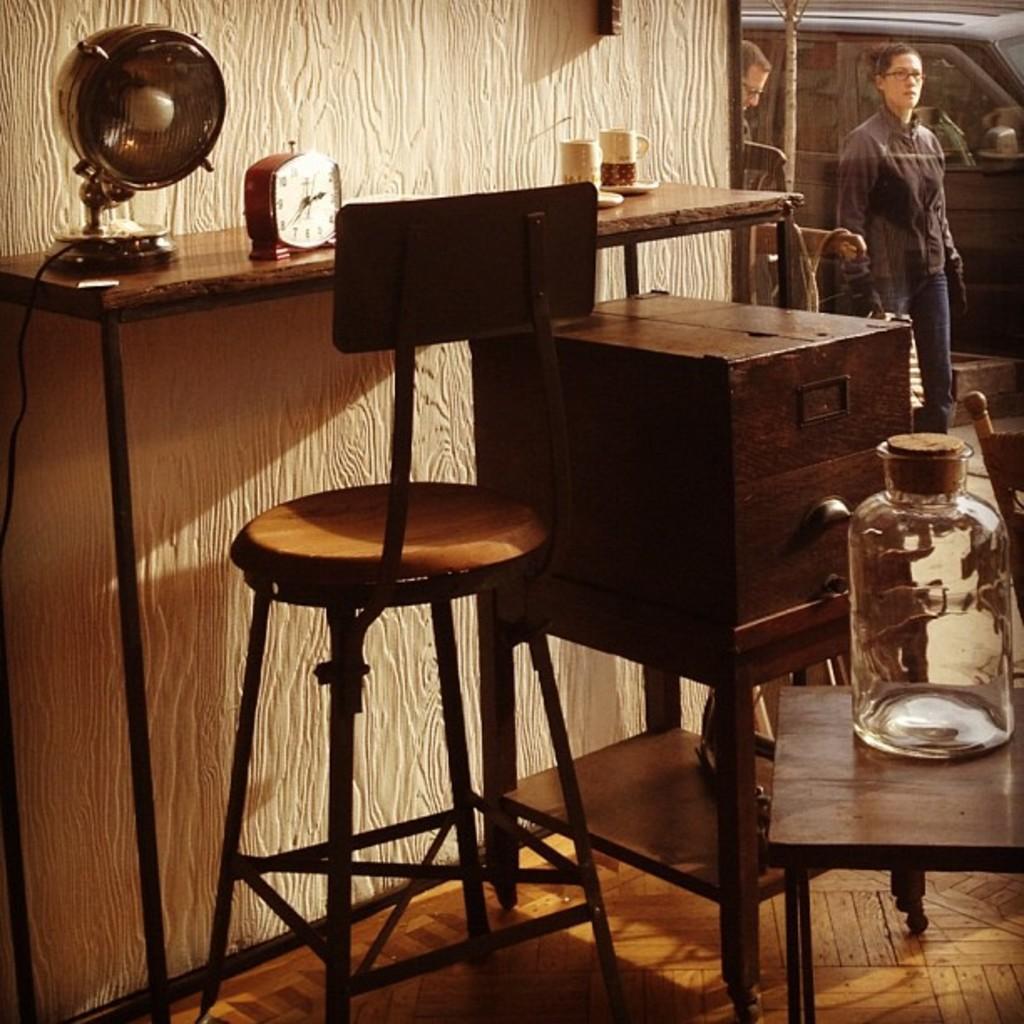Please provide a concise description of this image. The image is taken in the room. In the center of the image there is a chair. There is a table we can see a clock, light and cups placed on the table. There is a stand. We can see a jar. In the background there is a car and people. 